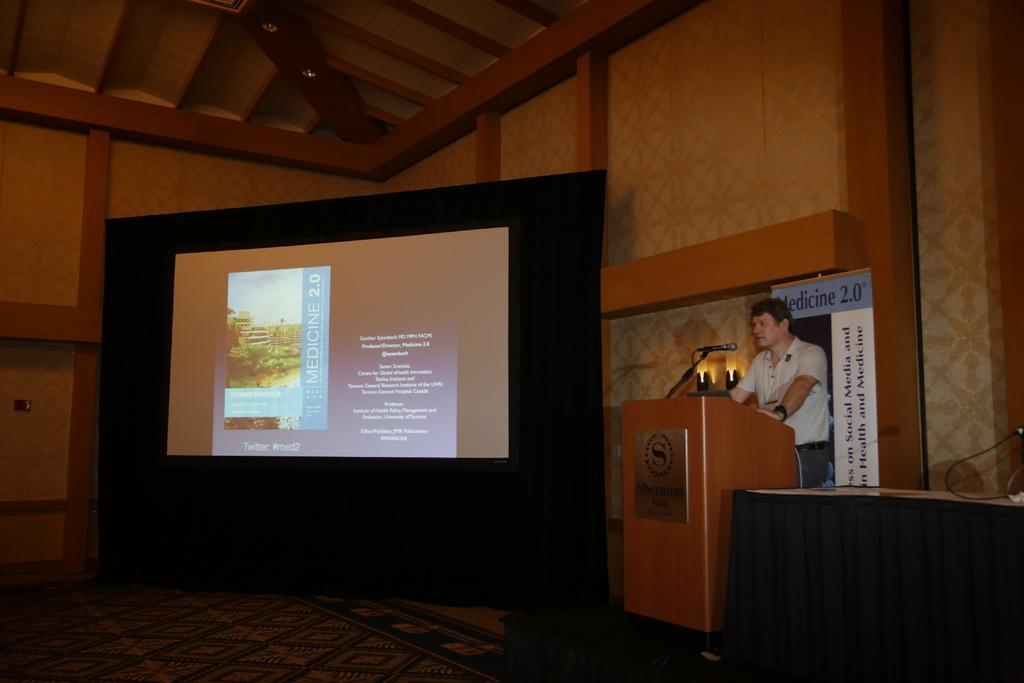Who is the main subject in the image? There is a man in the image. What is the man doing in the image? The man is standing in front of a table and speaking into a microphone. What is the purpose of the table in the image? The table is likely used to hold the microphone and other equipment. What is the projector screen used for in the image? The projector screen is likely used for displaying visual aids or presentations. What type of mine is visible in the image? There is no mine present in the image. Is the man in the image a lawyer? The image does not provide any information about the man's profession, so we cannot determine if he is a lawyer. 